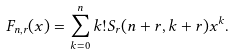<formula> <loc_0><loc_0><loc_500><loc_500>F _ { n , r } ( x ) = \sum _ { k = 0 } ^ { n } k ! S _ { r } ( n + r , k + r ) x ^ { k } .</formula> 